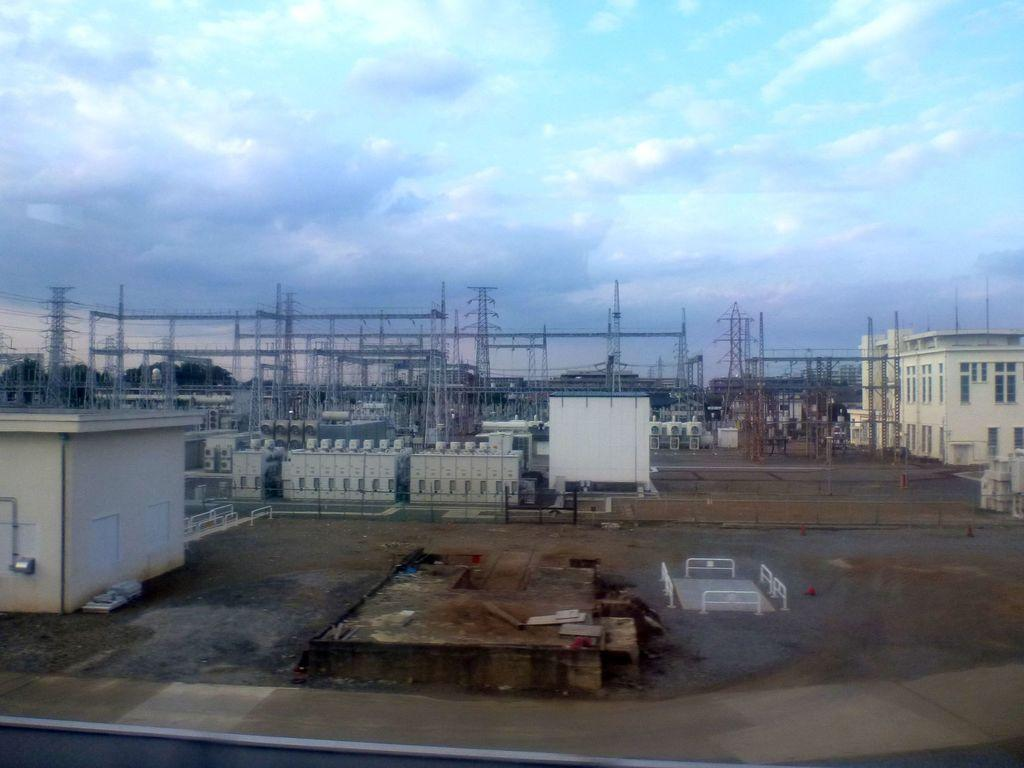What type of structure is present in the image? There is a building in the image. What other objects can be seen in the image? There are poles, towers, and devices visible in the image. What is visible in the background of the image? The sky is visible in the background of the image. What can be observed in the sky? There are clouds in the sky. Can you describe the maid's outfit in the image? There is no maid present in the image, so it is not possible to describe her outfit. 